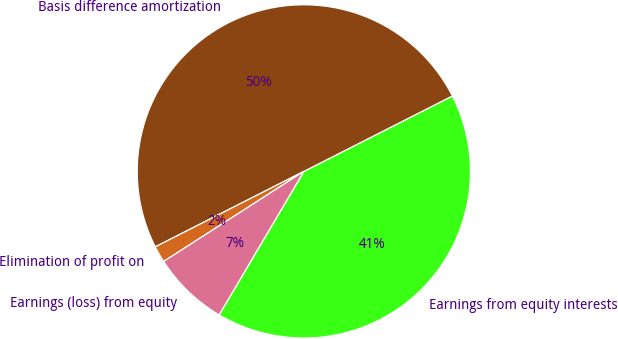Convert chart. <chart><loc_0><loc_0><loc_500><loc_500><pie_chart><fcel>Earnings from equity interests<fcel>Basis difference amortization<fcel>Elimination of profit on<fcel>Earnings (loss) from equity<nl><fcel>40.97%<fcel>50.0%<fcel>1.61%<fcel>7.42%<nl></chart> 